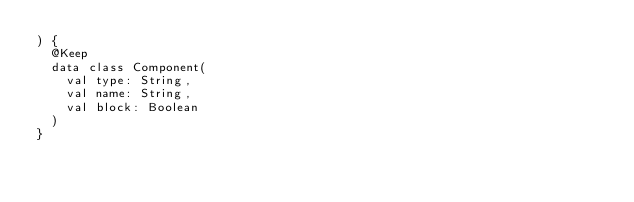Convert code to text. <code><loc_0><loc_0><loc_500><loc_500><_Kotlin_>) {
  @Keep
  data class Component(
    val type: String,
    val name: String,
    val block: Boolean
  )
}
</code> 